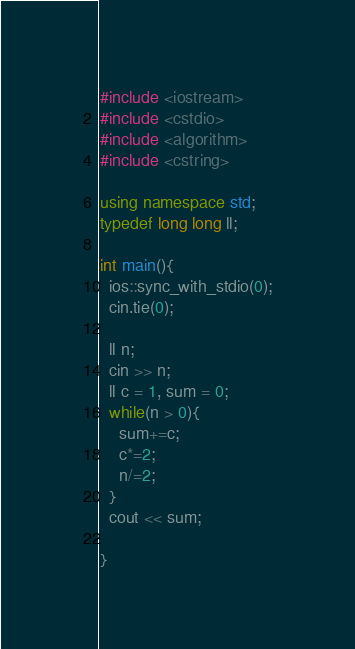<code> <loc_0><loc_0><loc_500><loc_500><_C++_>#include <iostream>
#include <cstdio>
#include <algorithm>
#include <cstring>

using namespace std;
typedef long long ll;

int main(){
  ios::sync_with_stdio(0);
  cin.tie(0);

  ll n;
  cin >> n;
  ll c = 1, sum = 0;
  while(n > 0){
    sum+=c;
    c*=2;
    n/=2;
  }
  cout << sum;

}
</code> 